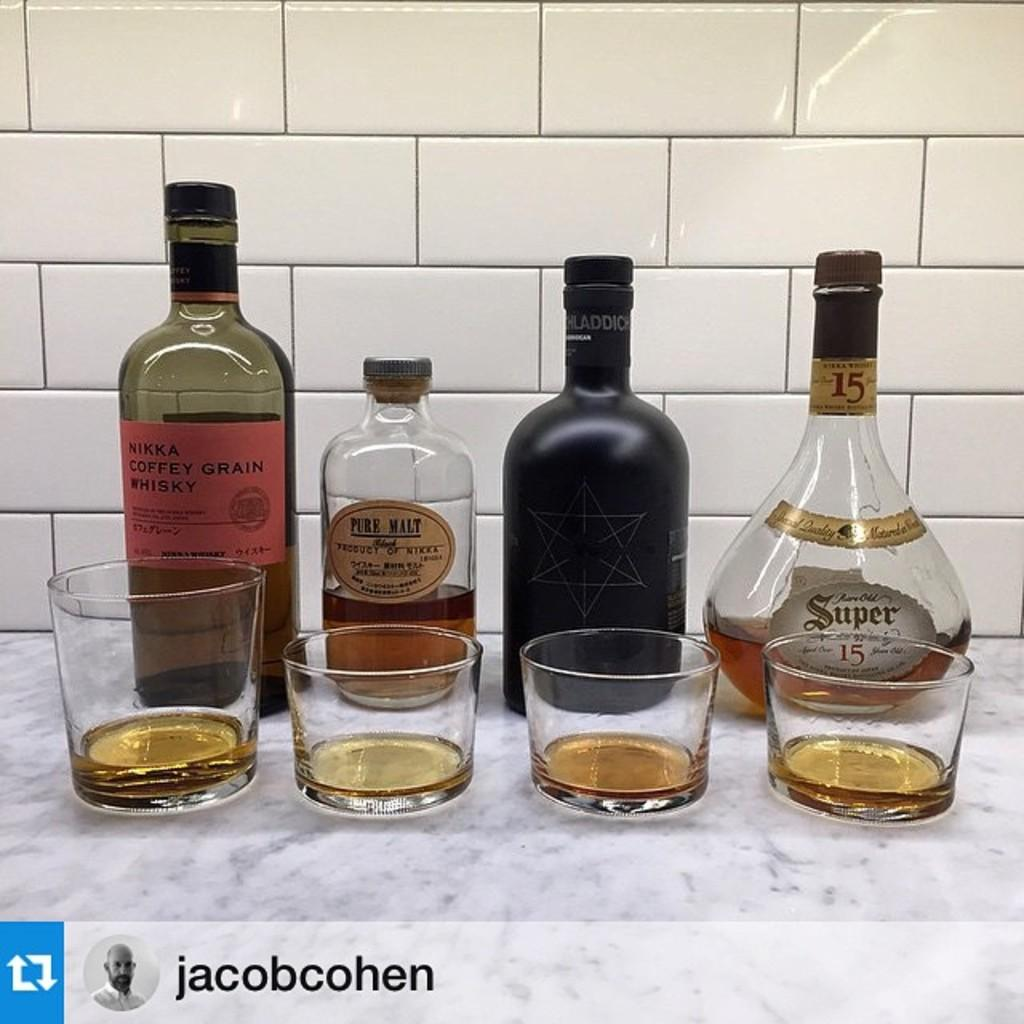What type of flooring is visible in the background of the image? There are white color tiles in the background. What can be seen inside the glasses in the image? There are glasses with a drink in the image. What else is visible behind the glasses in the image? There are bottles visible behind the glasses. What type of grain is being selected by the goat in the image? There is no goat present in the image, so it is not possible to answer that question. 